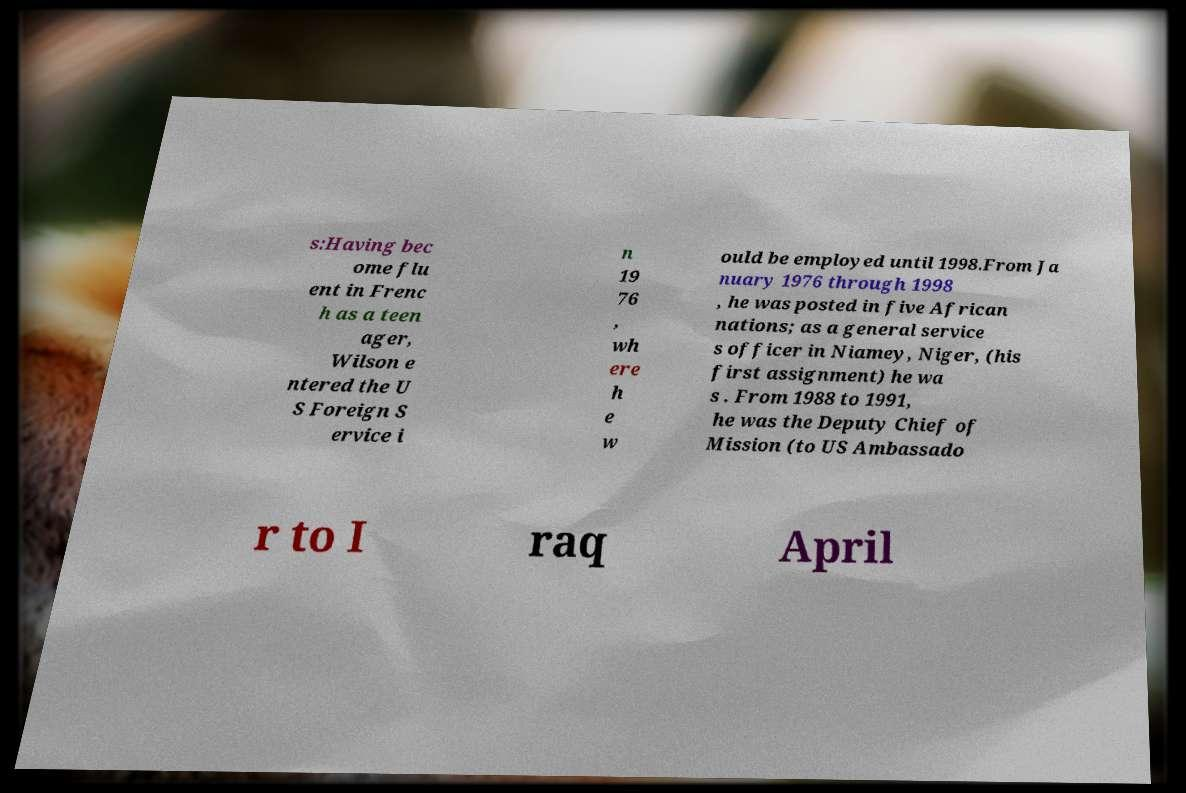I need the written content from this picture converted into text. Can you do that? s:Having bec ome flu ent in Frenc h as a teen ager, Wilson e ntered the U S Foreign S ervice i n 19 76 , wh ere h e w ould be employed until 1998.From Ja nuary 1976 through 1998 , he was posted in five African nations; as a general service s officer in Niamey, Niger, (his first assignment) he wa s . From 1988 to 1991, he was the Deputy Chief of Mission (to US Ambassado r to I raq April 